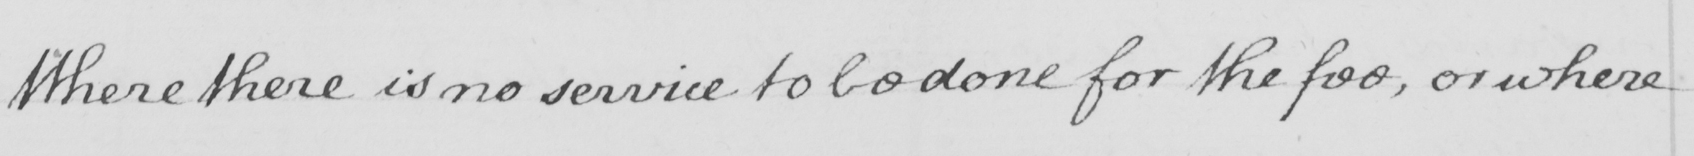Transcribe the text shown in this historical manuscript line. Where there is no service to be done for the fee , or where 